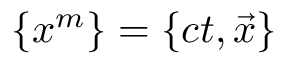Convert formula to latex. <formula><loc_0><loc_0><loc_500><loc_500>\{ x ^ { m } \} = \{ c t , { \vec { x } } \}</formula> 